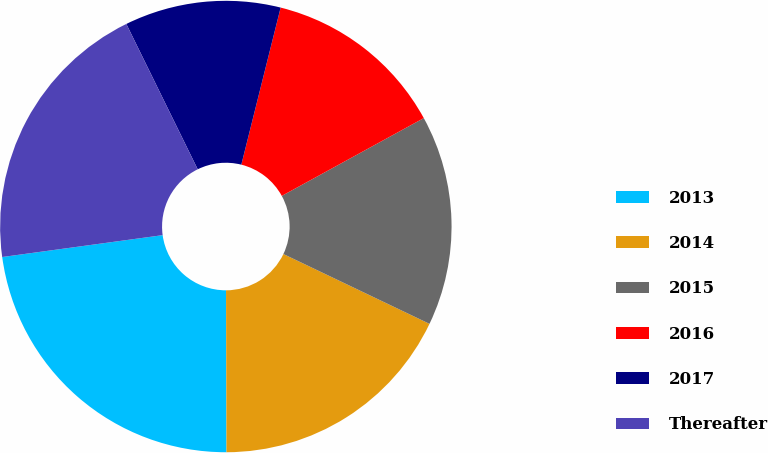<chart> <loc_0><loc_0><loc_500><loc_500><pie_chart><fcel>2013<fcel>2014<fcel>2015<fcel>2016<fcel>2017<fcel>Thereafter<nl><fcel>22.89%<fcel>17.86%<fcel>15.07%<fcel>13.12%<fcel>11.17%<fcel>19.89%<nl></chart> 